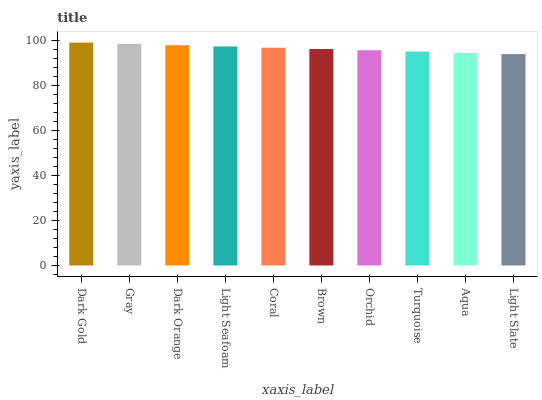Is Light Slate the minimum?
Answer yes or no. Yes. Is Dark Gold the maximum?
Answer yes or no. Yes. Is Gray the minimum?
Answer yes or no. No. Is Gray the maximum?
Answer yes or no. No. Is Dark Gold greater than Gray?
Answer yes or no. Yes. Is Gray less than Dark Gold?
Answer yes or no. Yes. Is Gray greater than Dark Gold?
Answer yes or no. No. Is Dark Gold less than Gray?
Answer yes or no. No. Is Coral the high median?
Answer yes or no. Yes. Is Brown the low median?
Answer yes or no. Yes. Is Light Seafoam the high median?
Answer yes or no. No. Is Aqua the low median?
Answer yes or no. No. 